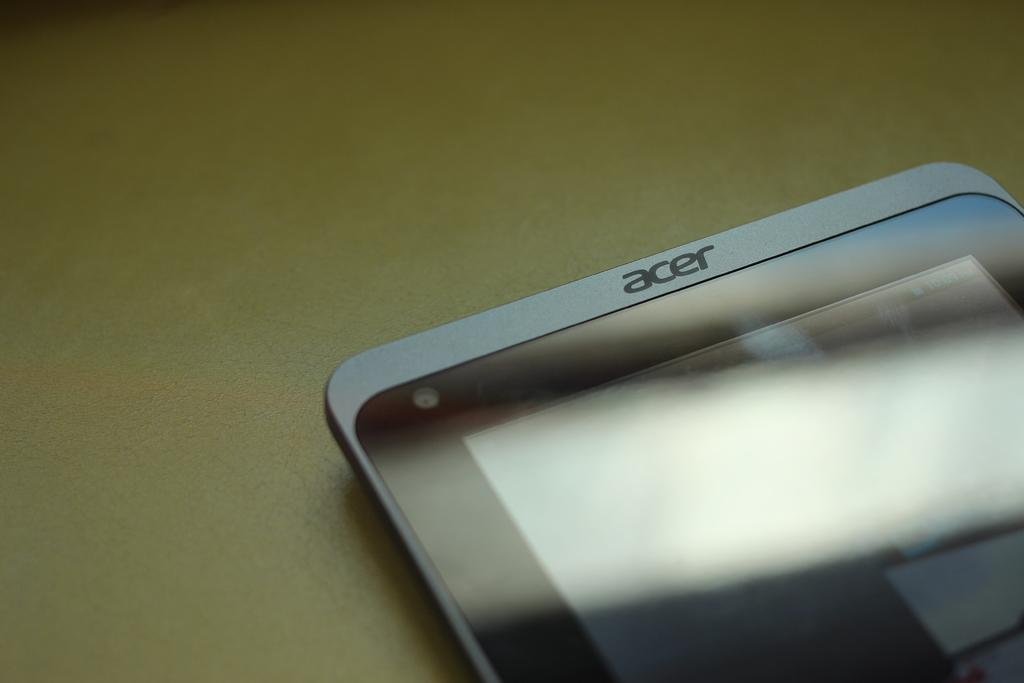<image>
Give a short and clear explanation of the subsequent image. the top of a grey acer phone on a tan table 